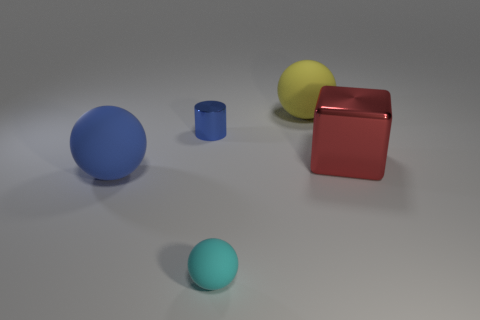How many other objects are the same shape as the blue metal thing?
Make the answer very short. 0. Do the sphere that is to the left of the blue shiny cylinder and the yellow rubber ball right of the blue metallic thing have the same size?
Make the answer very short. Yes. What number of spheres are either big yellow objects or blue things?
Provide a short and direct response. 2. What number of shiny things are either large brown cubes or tiny spheres?
Give a very brief answer. 0. The blue object that is the same shape as the large yellow matte thing is what size?
Give a very brief answer. Large. Is there any other thing that is the same size as the red metallic cube?
Ensure brevity in your answer.  Yes. Do the yellow ball and the blue object in front of the block have the same size?
Your response must be concise. Yes. What shape is the shiny thing that is left of the large red cube?
Keep it short and to the point. Cylinder. What is the color of the sphere that is right of the rubber ball in front of the big blue matte thing?
Offer a very short reply. Yellow. The other large thing that is the same shape as the big blue object is what color?
Make the answer very short. Yellow. 